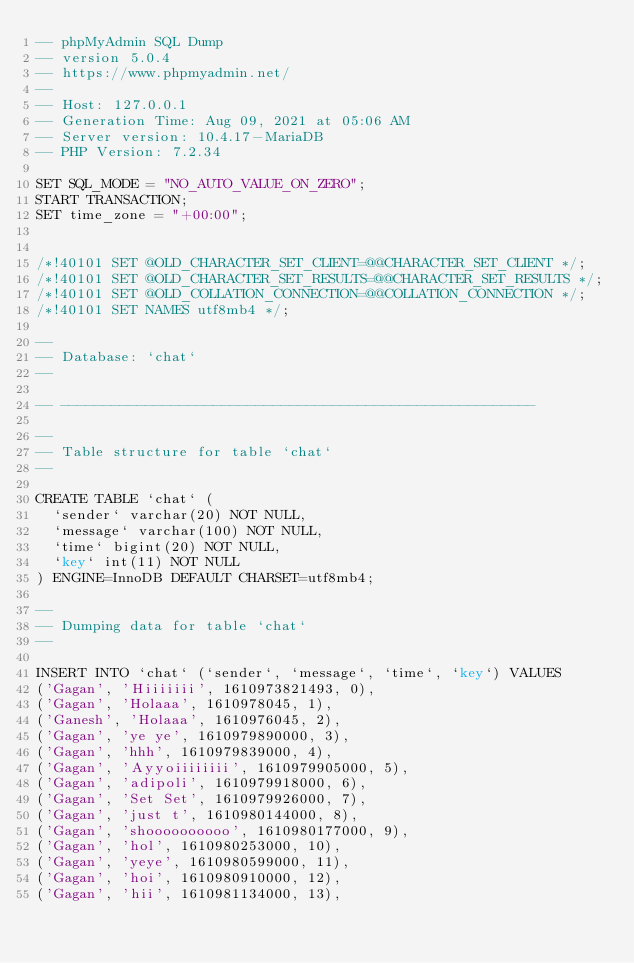<code> <loc_0><loc_0><loc_500><loc_500><_SQL_>-- phpMyAdmin SQL Dump
-- version 5.0.4
-- https://www.phpmyadmin.net/
--
-- Host: 127.0.0.1
-- Generation Time: Aug 09, 2021 at 05:06 AM
-- Server version: 10.4.17-MariaDB
-- PHP Version: 7.2.34

SET SQL_MODE = "NO_AUTO_VALUE_ON_ZERO";
START TRANSACTION;
SET time_zone = "+00:00";


/*!40101 SET @OLD_CHARACTER_SET_CLIENT=@@CHARACTER_SET_CLIENT */;
/*!40101 SET @OLD_CHARACTER_SET_RESULTS=@@CHARACTER_SET_RESULTS */;
/*!40101 SET @OLD_COLLATION_CONNECTION=@@COLLATION_CONNECTION */;
/*!40101 SET NAMES utf8mb4 */;

--
-- Database: `chat`
--

-- --------------------------------------------------------

--
-- Table structure for table `chat`
--

CREATE TABLE `chat` (
  `sender` varchar(20) NOT NULL,
  `message` varchar(100) NOT NULL,
  `time` bigint(20) NOT NULL,
  `key` int(11) NOT NULL
) ENGINE=InnoDB DEFAULT CHARSET=utf8mb4;

--
-- Dumping data for table `chat`
--

INSERT INTO `chat` (`sender`, `message`, `time`, `key`) VALUES
('Gagan', 'Hiiiiiii', 1610973821493, 0),
('Gagan', 'Holaaa', 1610978045, 1),
('Ganesh', 'Holaaa', 1610976045, 2),
('Gagan', 'ye ye', 1610979890000, 3),
('Gagan', 'hhh', 1610979839000, 4),
('Gagan', 'Ayyoiiiiiiii', 1610979905000, 5),
('Gagan', 'adipoli', 1610979918000, 6),
('Gagan', 'Set Set', 1610979926000, 7),
('Gagan', 'just t', 1610980144000, 8),
('Gagan', 'shoooooooooo', 1610980177000, 9),
('Gagan', 'hol', 1610980253000, 10),
('Gagan', 'yeye', 1610980599000, 11),
('Gagan', 'hoi', 1610980910000, 12),
('Gagan', 'hii', 1610981134000, 13),</code> 